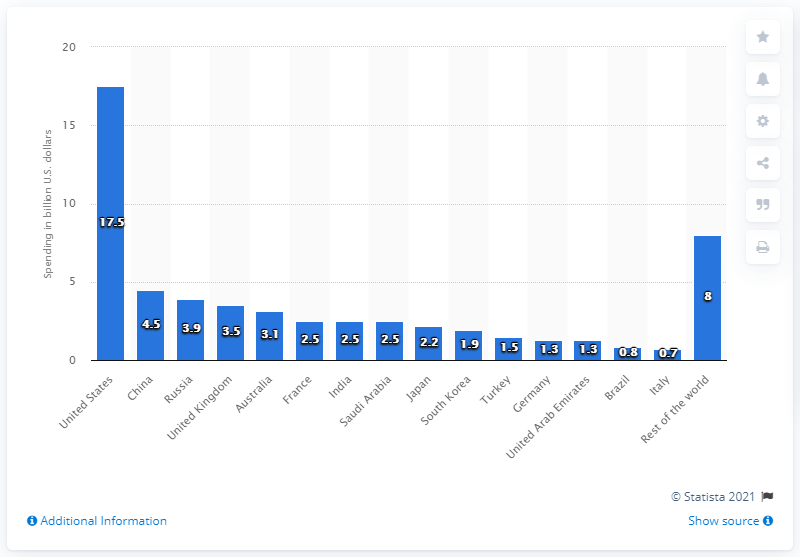Can you discuss how the U.S. drone spending compares with China and Russia? The U.S. spends significantly more on drones compared to China and Russia. The chart shows that while the U.S. spends $17.5 billion, China's expenditure stands at $4.5 billion and Russia's at $3.9 billion. 